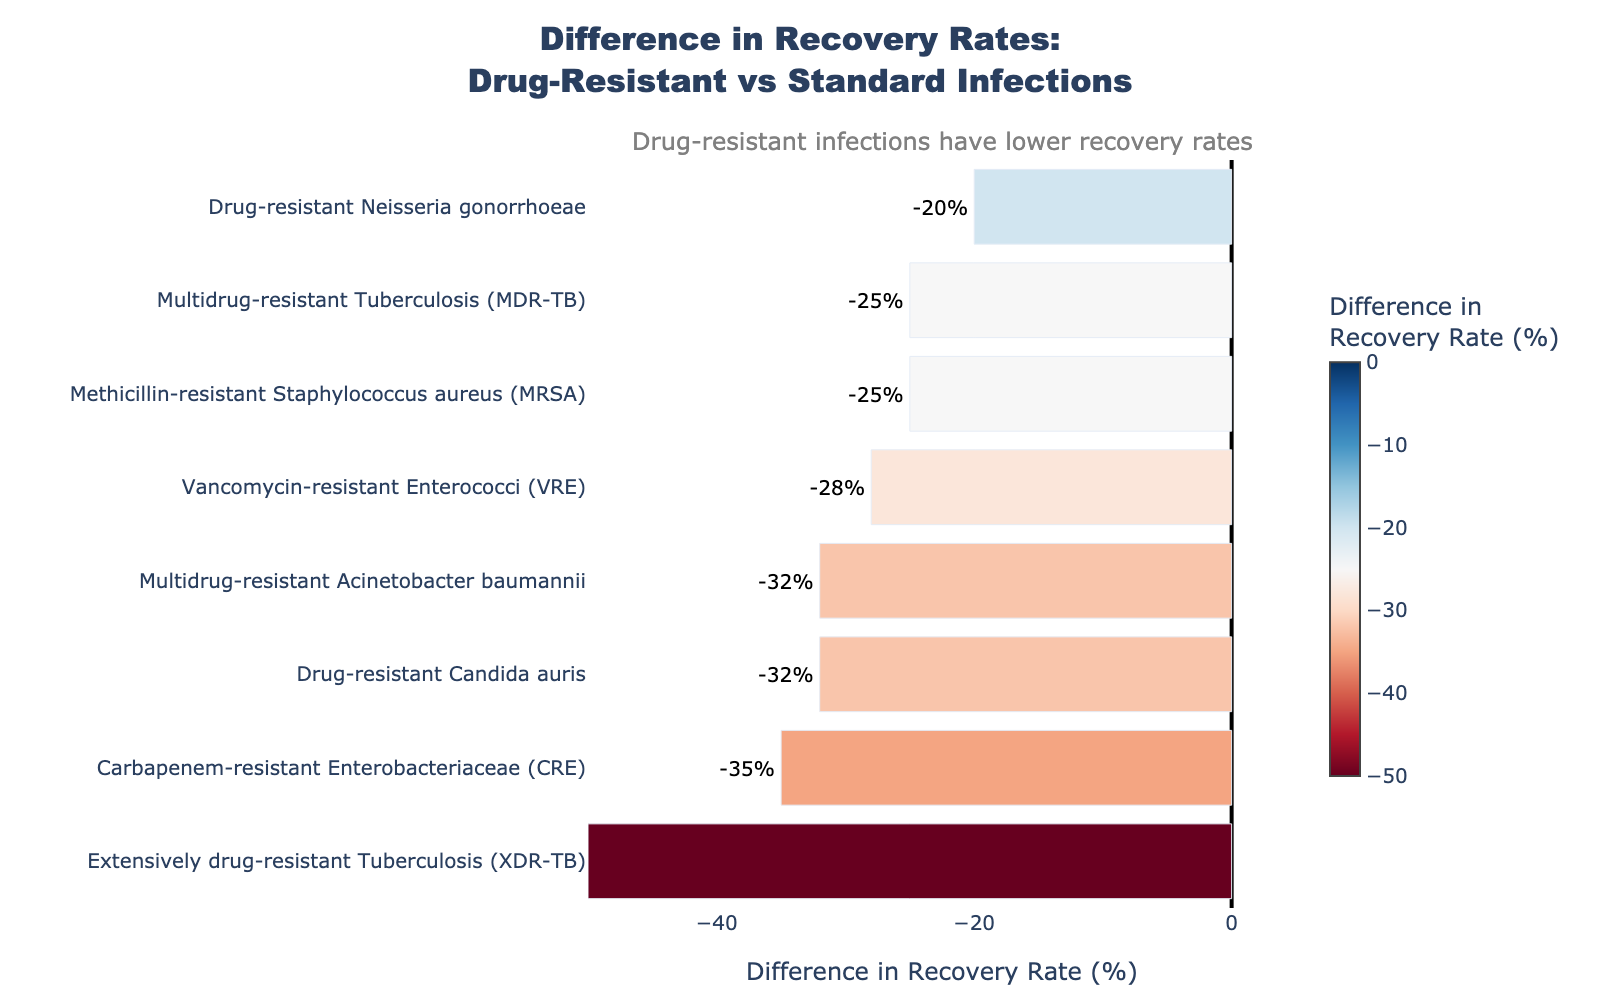What's the difference in recovery rate for Methicillin-resistant Staphylococcus aureus (MRSA) compared to standard infections? The figure shows that the difference for MRSA can be read directly from the length of the corresponding bar labeled with the text value. Check the start and end points of the labeled value.
Answer: -25% Which infection type has the largest negative difference in recovery rates between drug-resistant and standard infections? The infection type with the largest negative difference will have the longest bar extending to the left of the zero line. Look for the bar with the greatest negative value.
Answer: Extensively drug-resistant Tuberculosis (XDR-TB) How does the recovery rate for Drug-resistant Neisseria gonorrhoeae compare to that for Drug-resistant Candida auris? Compare the difference between drug-resistant and standard infection recovery rates for both infection types by examining the respective bar lengths and directions. Drug-resistant Neisseria gonorrhoeae's bar is shorter and closer to zero than that of Drug-resistant Candida auris.
Answer: Drug-resistant Neisseria gonorrhoeae has a less negative difference (-20%) compared to Drug-resistant Candida auris (-32%) Which infection types have a difference in recovery rates of more than -30%? Identify the bars that extend to the left by more than 30 units, indicating a difference of more than -30%. Cross-check with their labels.
Answer: Carbapenem-resistant Enterobacteriaceae (CRE), Extensively drug-resistant Tuberculosis (XDR-TB), Drug-resistant Candida auris On average, which type of infection, drug-resistant Tuberculosis (MDR-TB), or drug-resistant Acinetobacter baumannii, has a higher recovery rate? Compare the actual recovery rates of MDR-TB (60%) and Multidrug-resistant Acinetobacter baumannii (50%). The highest value indicates the higher recovery rate.
Answer: Multidrug-resistant Tuberculosis (MDR-TB) Which infection has the smallest negative difference from the standard infection recovery rate? The bar closest to zero on the left side indicates the smallest negative difference. Check the label next to it.
Answer: Drug-resistant Neisseria gonorrhoeae (-20%) How many infections have a recovery rate difference worse than -30% but better than -40%? Identify bars that have differences within the range of -30% and -40%. Count these bars to get the answer.
Answer: 2 (Carbapenem-resistant Enterobacteriaceae (CRE) and Drug-resistant Candida auris) 